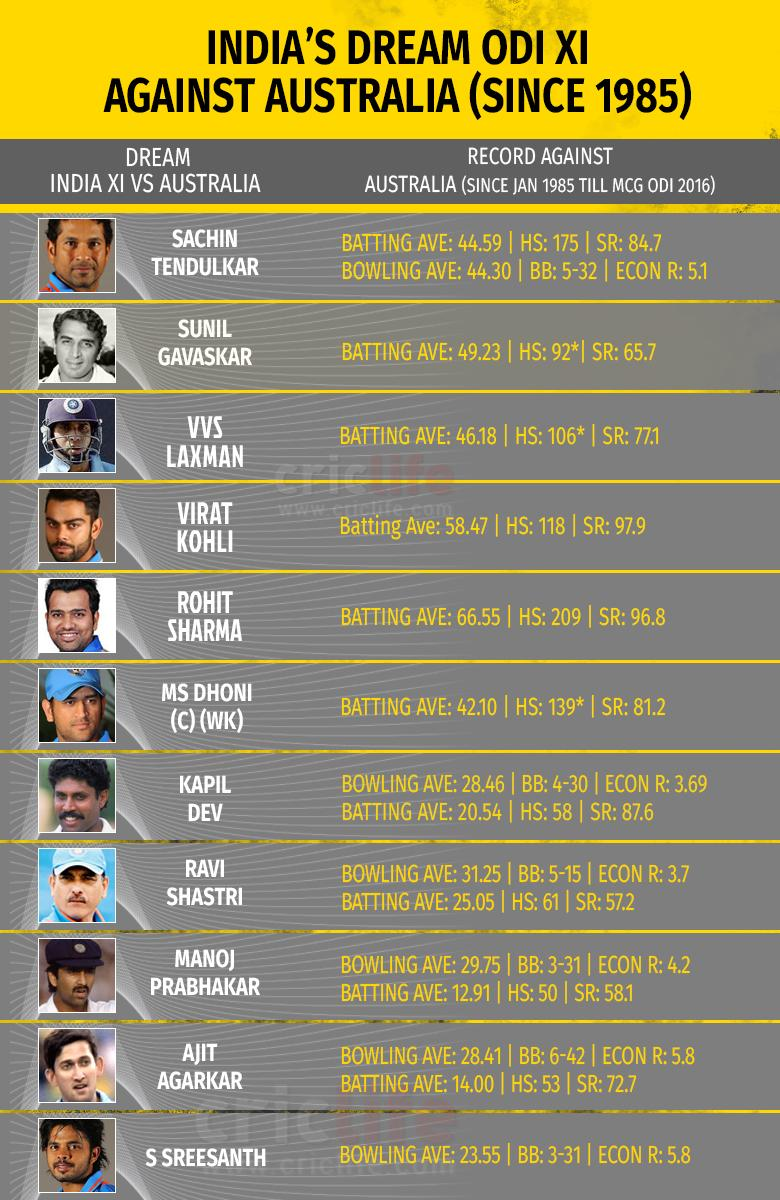Specify some key components in this picture. Rohit Sharma is the player who scored the highest batting average against Australia in One Day Internationals. The highest bowling average scored in an ODI against Australia is 44.30. The lowest batting average scored in an ODI against Australia was 12.91. 